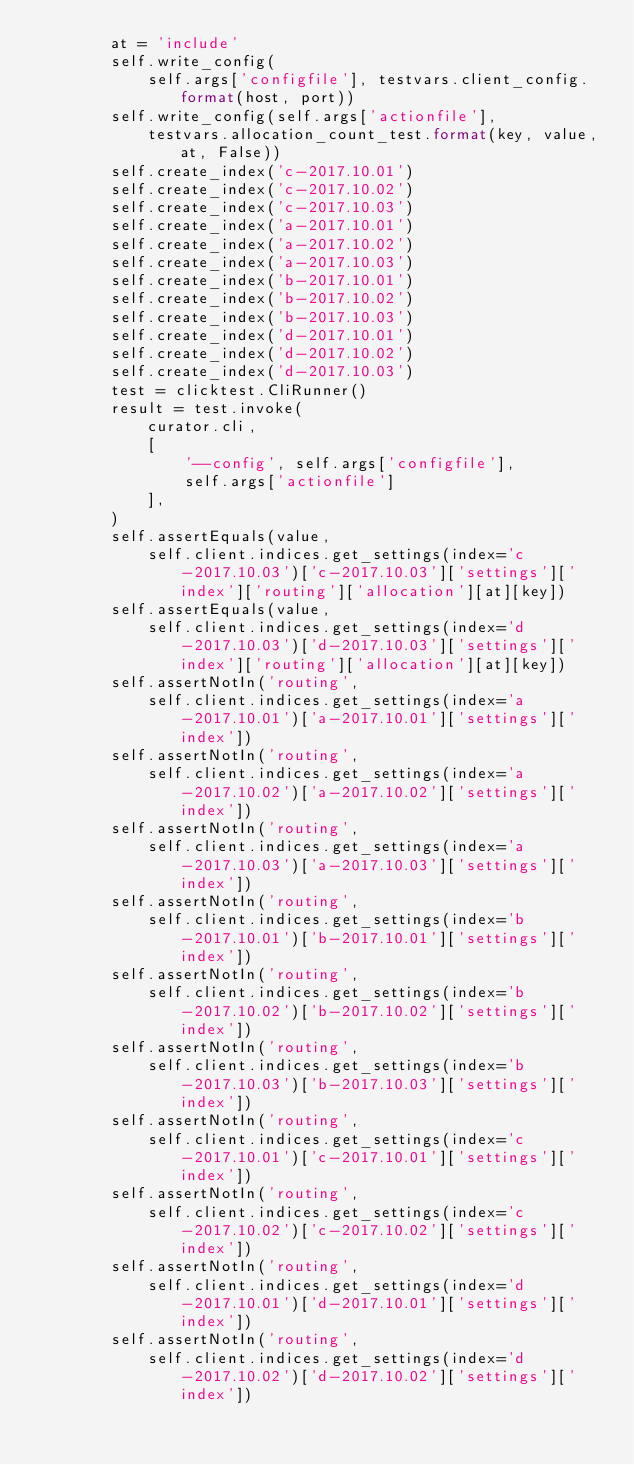<code> <loc_0><loc_0><loc_500><loc_500><_Python_>        at = 'include'
        self.write_config(
            self.args['configfile'], testvars.client_config.format(host, port))
        self.write_config(self.args['actionfile'],
            testvars.allocation_count_test.format(key, value, at, False))
        self.create_index('c-2017.10.01')
        self.create_index('c-2017.10.02')
        self.create_index('c-2017.10.03')
        self.create_index('a-2017.10.01')
        self.create_index('a-2017.10.02')
        self.create_index('a-2017.10.03')
        self.create_index('b-2017.10.01')
        self.create_index('b-2017.10.02')
        self.create_index('b-2017.10.03')
        self.create_index('d-2017.10.01')
        self.create_index('d-2017.10.02')
        self.create_index('d-2017.10.03')
        test = clicktest.CliRunner()
        result = test.invoke(
            curator.cli,
            [
                '--config', self.args['configfile'],
                self.args['actionfile']
            ],
        )
        self.assertEquals(value,
            self.client.indices.get_settings(index='c-2017.10.03')['c-2017.10.03']['settings']['index']['routing']['allocation'][at][key])
        self.assertEquals(value,
            self.client.indices.get_settings(index='d-2017.10.03')['d-2017.10.03']['settings']['index']['routing']['allocation'][at][key])
        self.assertNotIn('routing',
            self.client.indices.get_settings(index='a-2017.10.01')['a-2017.10.01']['settings']['index'])
        self.assertNotIn('routing',
            self.client.indices.get_settings(index='a-2017.10.02')['a-2017.10.02']['settings']['index'])
        self.assertNotIn('routing',
            self.client.indices.get_settings(index='a-2017.10.03')['a-2017.10.03']['settings']['index'])
        self.assertNotIn('routing',
            self.client.indices.get_settings(index='b-2017.10.01')['b-2017.10.01']['settings']['index'])
        self.assertNotIn('routing',
            self.client.indices.get_settings(index='b-2017.10.02')['b-2017.10.02']['settings']['index'])
        self.assertNotIn('routing',
            self.client.indices.get_settings(index='b-2017.10.03')['b-2017.10.03']['settings']['index'])
        self.assertNotIn('routing',
            self.client.indices.get_settings(index='c-2017.10.01')['c-2017.10.01']['settings']['index'])
        self.assertNotIn('routing',
            self.client.indices.get_settings(index='c-2017.10.02')['c-2017.10.02']['settings']['index'])
        self.assertNotIn('routing',
            self.client.indices.get_settings(index='d-2017.10.01')['d-2017.10.01']['settings']['index'])
        self.assertNotIn('routing',
            self.client.indices.get_settings(index='d-2017.10.02')['d-2017.10.02']['settings']['index'])
</code> 